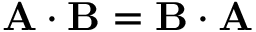<formula> <loc_0><loc_0><loc_500><loc_500>A \cdot B = B \cdot A</formula> 